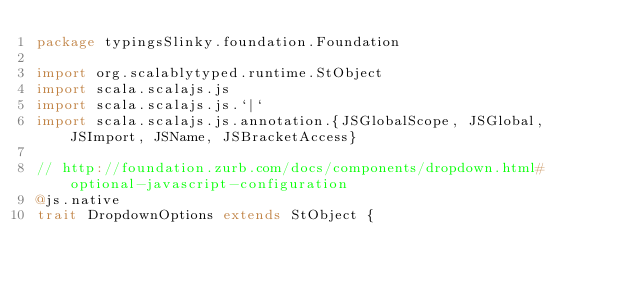Convert code to text. <code><loc_0><loc_0><loc_500><loc_500><_Scala_>package typingsSlinky.foundation.Foundation

import org.scalablytyped.runtime.StObject
import scala.scalajs.js
import scala.scalajs.js.`|`
import scala.scalajs.js.annotation.{JSGlobalScope, JSGlobal, JSImport, JSName, JSBracketAccess}

// http://foundation.zurb.com/docs/components/dropdown.html#optional-javascript-configuration
@js.native
trait DropdownOptions extends StObject {
  </code> 